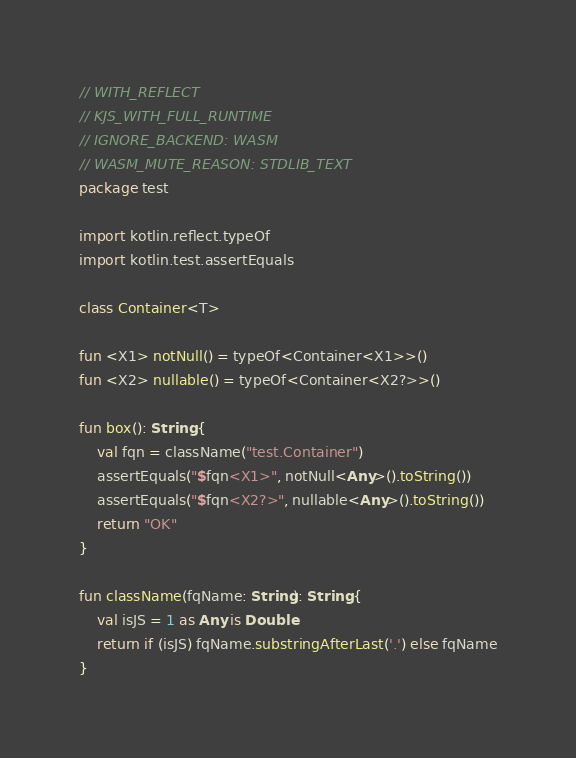Convert code to text. <code><loc_0><loc_0><loc_500><loc_500><_Kotlin_>// WITH_REFLECT
// KJS_WITH_FULL_RUNTIME
// IGNORE_BACKEND: WASM
// WASM_MUTE_REASON: STDLIB_TEXT
package test

import kotlin.reflect.typeOf
import kotlin.test.assertEquals

class Container<T>

fun <X1> notNull() = typeOf<Container<X1>>()
fun <X2> nullable() = typeOf<Container<X2?>>()

fun box(): String {
    val fqn = className("test.Container")
    assertEquals("$fqn<X1>", notNull<Any>().toString())
    assertEquals("$fqn<X2?>", nullable<Any>().toString())
    return "OK"
}

fun className(fqName: String): String {
    val isJS = 1 as Any is Double
    return if (isJS) fqName.substringAfterLast('.') else fqName
}
</code> 